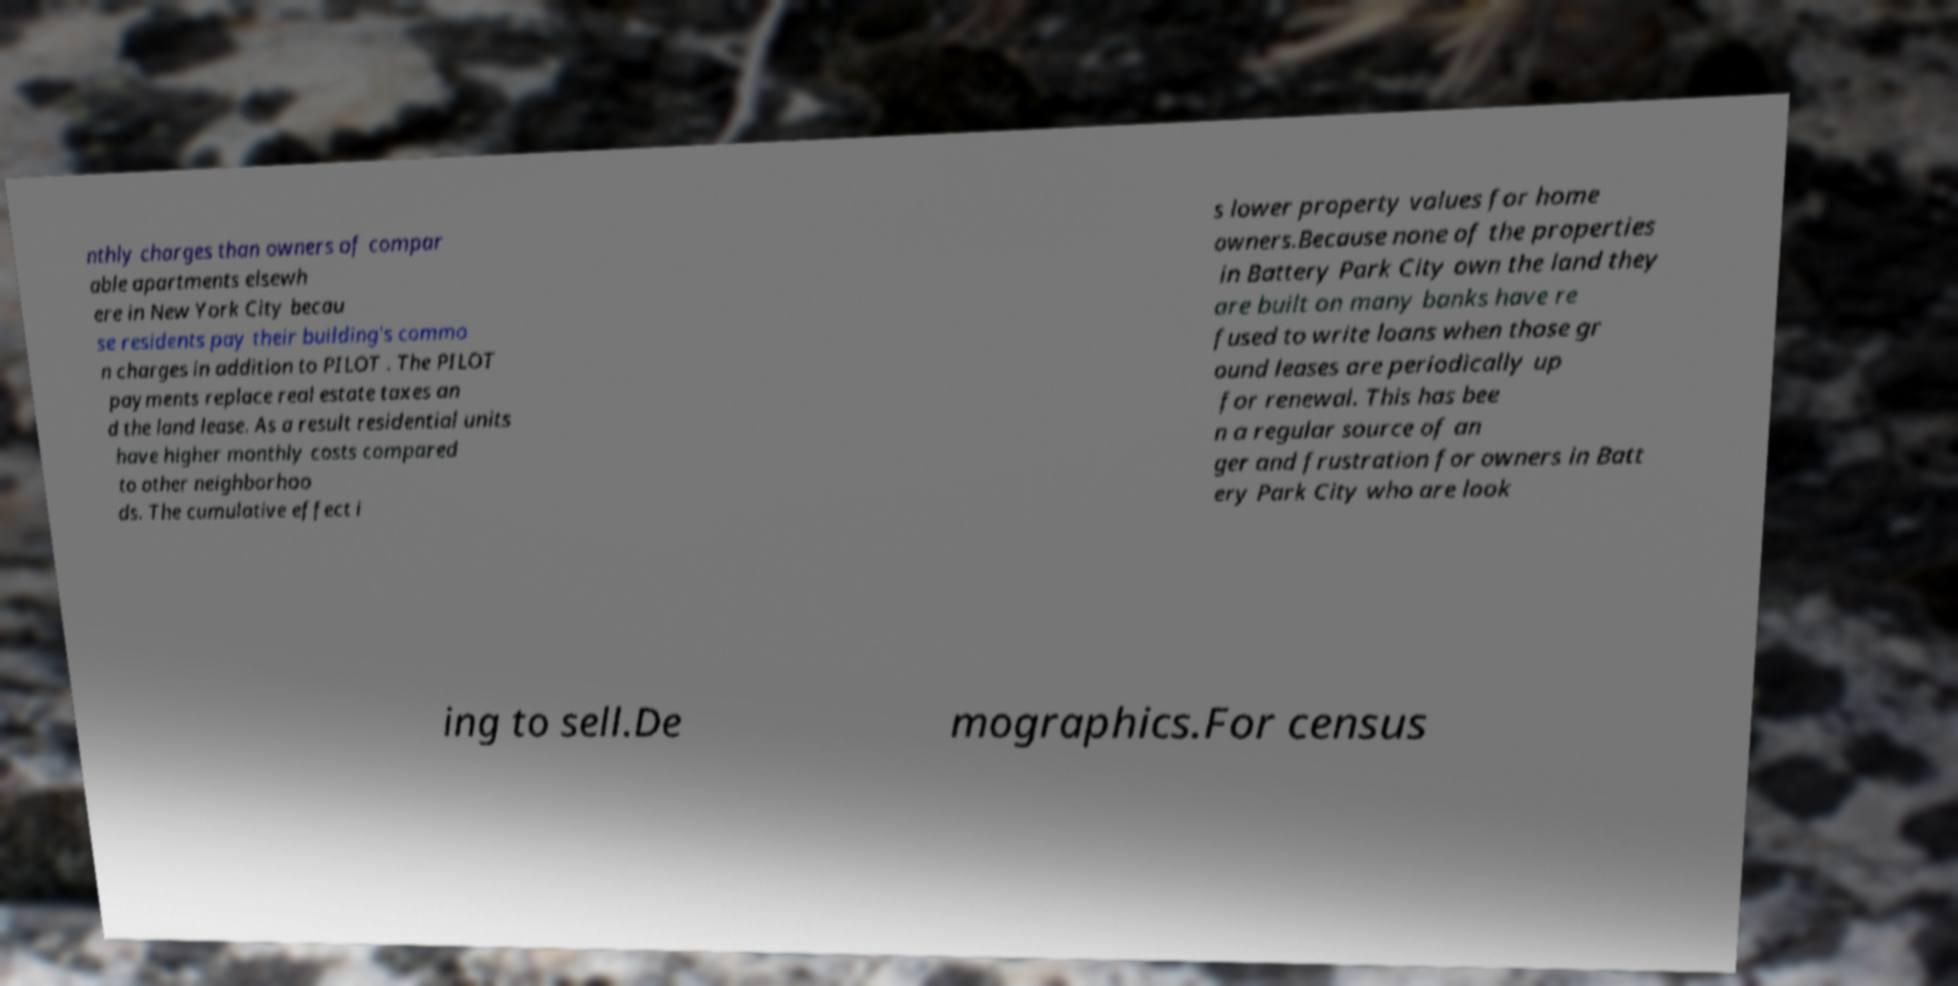There's text embedded in this image that I need extracted. Can you transcribe it verbatim? nthly charges than owners of compar able apartments elsewh ere in New York City becau se residents pay their building's commo n charges in addition to PILOT . The PILOT payments replace real estate taxes an d the land lease. As a result residential units have higher monthly costs compared to other neighborhoo ds. The cumulative effect i s lower property values for home owners.Because none of the properties in Battery Park City own the land they are built on many banks have re fused to write loans when those gr ound leases are periodically up for renewal. This has bee n a regular source of an ger and frustration for owners in Batt ery Park City who are look ing to sell.De mographics.For census 